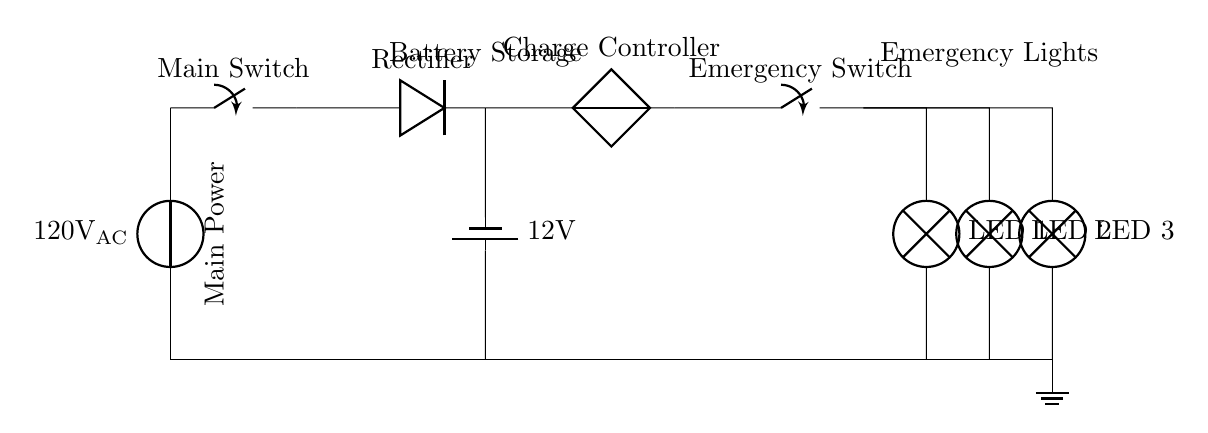What is the main power supply voltage? The voltage indicated for the main power supply is 120 volts alternating current, which is labeled in the diagram.
Answer: 120 volts AC What is the purpose of the rectifier in the circuit? The rectifier converts the alternating current from the main power supply into direct current before it reaches the battery storage. This is necessary for charging the battery.
Answer: Charge battery How many emergency lights are present in this circuit? The circuit diagram shows a total of three emergency lights, which are labeled as LED. They are located after the emergency switch.
Answer: Three What is the voltage of the battery storage? The battery storage is labeled with a voltage of 12 volts, indicating the potential difference that the battery can provide to the connected lights.
Answer: 12 volts What components are connected to the ground? The ground connections in the circuit are made from various points, specifically all the components below the line labeled for the ground, including the battery and LED lights.
Answer: Battery and LEDs Which component controls the charging of the battery? The charge controller is specifically designed to manage the charging process of the battery making sure the battery is charged correctly from the rectified output.
Answer: Charge controller 